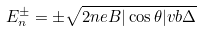<formula> <loc_0><loc_0><loc_500><loc_500>E _ { n } ^ { \pm } = \pm \sqrt { 2 n e B | \cos \theta | v b \Delta }</formula> 